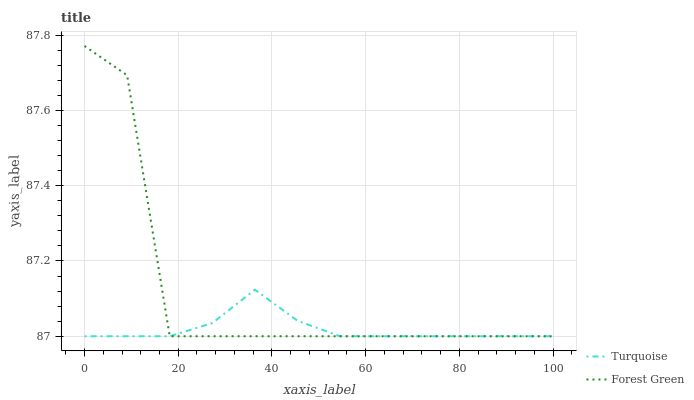Does Turquoise have the minimum area under the curve?
Answer yes or no. Yes. Does Forest Green have the maximum area under the curve?
Answer yes or no. Yes. Does Forest Green have the minimum area under the curve?
Answer yes or no. No. Is Turquoise the smoothest?
Answer yes or no. Yes. Is Forest Green the roughest?
Answer yes or no. Yes. Is Forest Green the smoothest?
Answer yes or no. No. Does Turquoise have the lowest value?
Answer yes or no. Yes. Does Forest Green have the highest value?
Answer yes or no. Yes. Does Forest Green intersect Turquoise?
Answer yes or no. Yes. Is Forest Green less than Turquoise?
Answer yes or no. No. Is Forest Green greater than Turquoise?
Answer yes or no. No. 